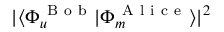Convert formula to latex. <formula><loc_0><loc_0><loc_500><loc_500>| \langle { \Phi _ { u } ^ { B o b } } | { \Phi _ { m } ^ { A l i c e } } \rangle | ^ { 2 }</formula> 